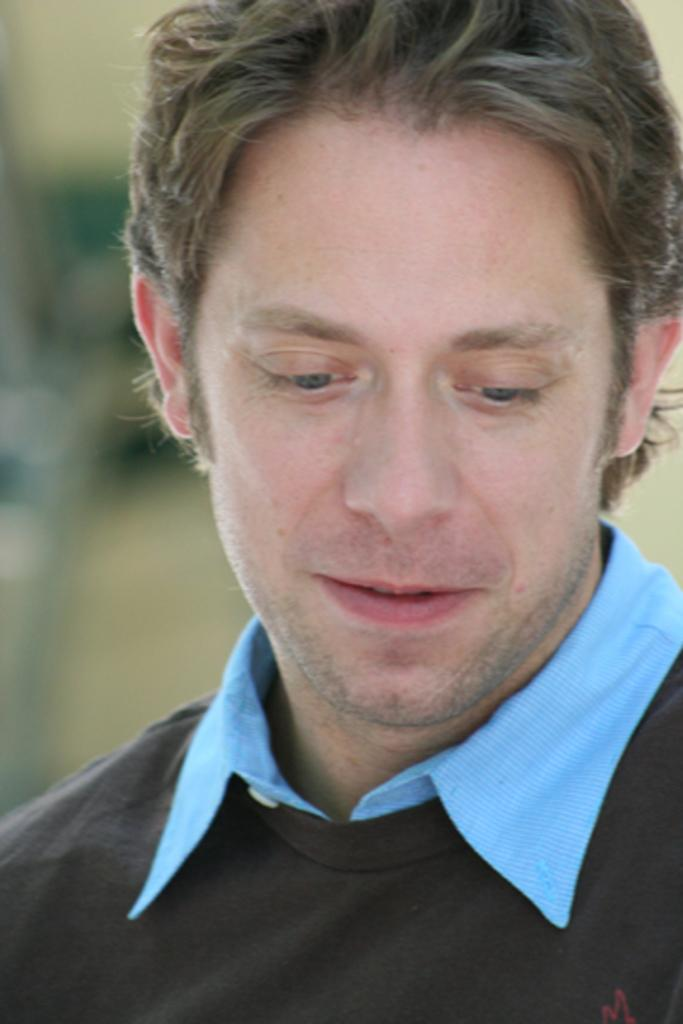What is the main subject of the image? There is a man in the image. What is the man wearing? The man is wearing a black dress. Can you describe the background of the image? The background of the image is blurry. What type of shoe can be seen on the man's hand in the image? There is no shoe present in the image, nor is there any indication that the man's hand is involved. 